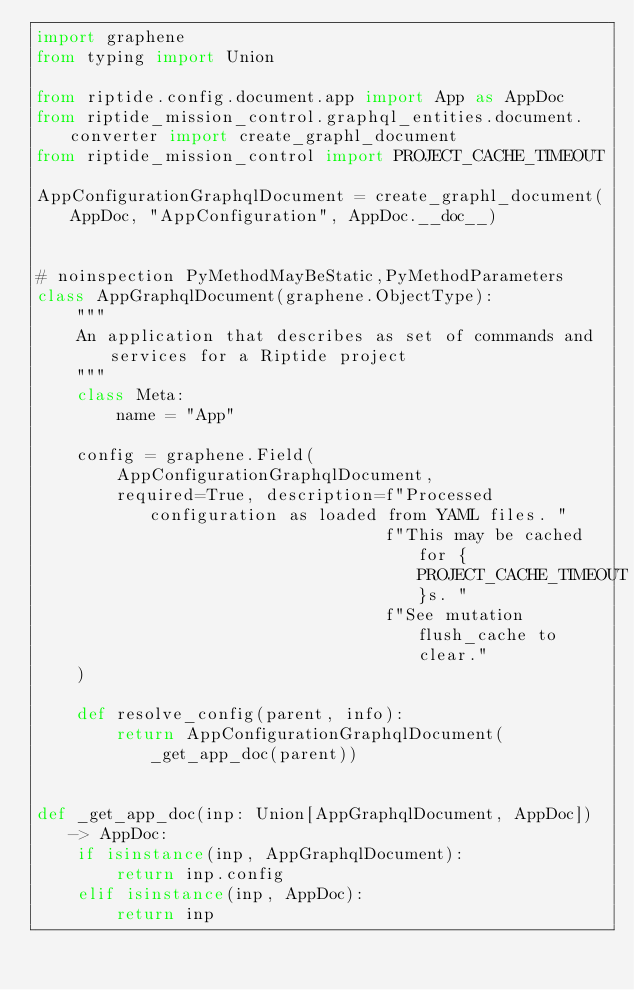<code> <loc_0><loc_0><loc_500><loc_500><_Python_>import graphene
from typing import Union

from riptide.config.document.app import App as AppDoc
from riptide_mission_control.graphql_entities.document.converter import create_graphl_document
from riptide_mission_control import PROJECT_CACHE_TIMEOUT

AppConfigurationGraphqlDocument = create_graphl_document(AppDoc, "AppConfiguration", AppDoc.__doc__)


# noinspection PyMethodMayBeStatic,PyMethodParameters
class AppGraphqlDocument(graphene.ObjectType):
    """
    An application that describes as set of commands and services for a Riptide project
    """
    class Meta:
        name = "App"

    config = graphene.Field(
        AppConfigurationGraphqlDocument,
        required=True, description=f"Processed configuration as loaded from YAML files. "
                                   f"This may be cached for {PROJECT_CACHE_TIMEOUT}s. "
                                   f"See mutation flush_cache to clear."
    )

    def resolve_config(parent, info):
        return AppConfigurationGraphqlDocument(_get_app_doc(parent))


def _get_app_doc(inp: Union[AppGraphqlDocument, AppDoc]) -> AppDoc:
    if isinstance(inp, AppGraphqlDocument):
        return inp.config
    elif isinstance(inp, AppDoc):
        return inp
</code> 